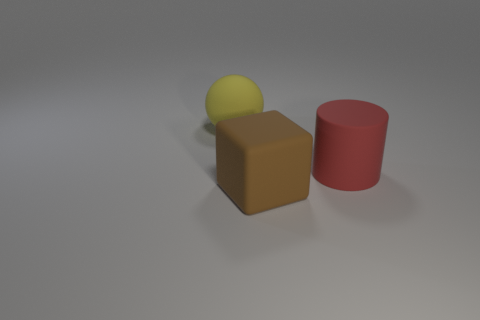What materials do the objects in the image appear to be made of? The objects in the image seem to be computer-generated and mimic common materials. The yellow sphere has a matte finish suggestive of a plastic or rubber material. The brown block resembles wood or particleboard, while the red cylinder looks like it could be a painted metal or plastic due to its reflective surface. 